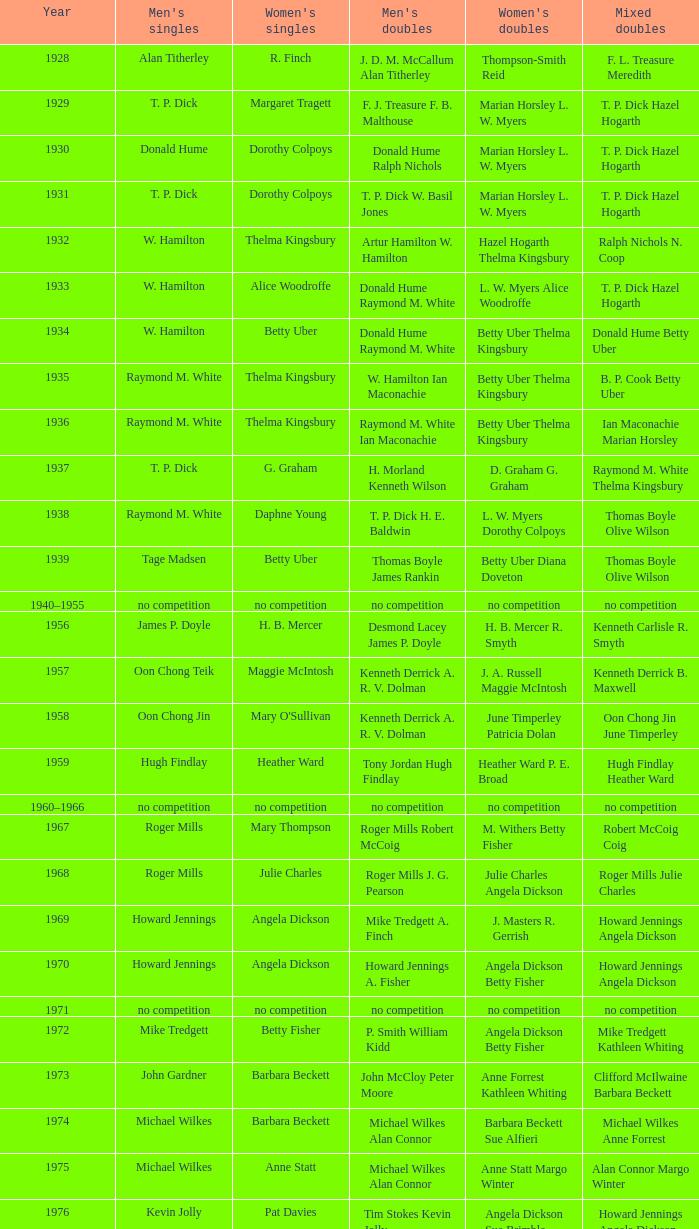Who won the Women's singles, in the year that Raymond M. White won the Men's singles and that W. Hamilton Ian Maconachie won the Men's doubles? Thelma Kingsbury. 